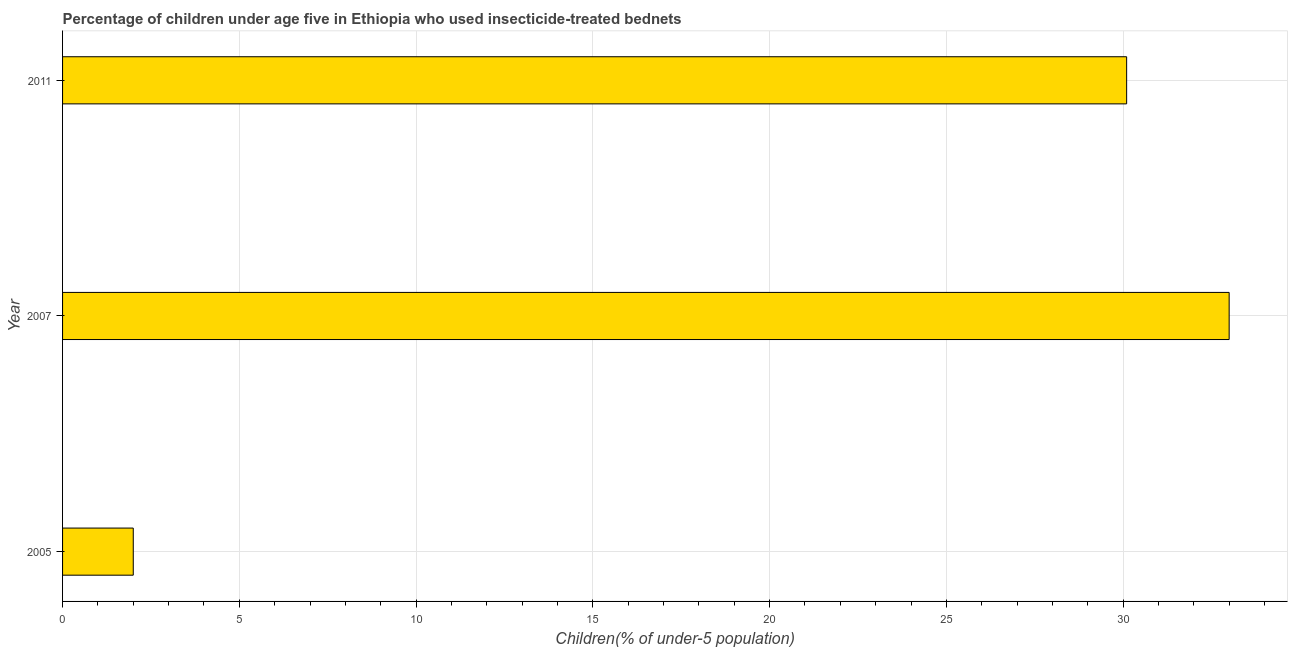What is the title of the graph?
Keep it short and to the point. Percentage of children under age five in Ethiopia who used insecticide-treated bednets. What is the label or title of the X-axis?
Offer a very short reply. Children(% of under-5 population). Across all years, what is the maximum percentage of children who use of insecticide-treated bed nets?
Your answer should be very brief. 33. Across all years, what is the minimum percentage of children who use of insecticide-treated bed nets?
Ensure brevity in your answer.  2. In which year was the percentage of children who use of insecticide-treated bed nets minimum?
Provide a succinct answer. 2005. What is the sum of the percentage of children who use of insecticide-treated bed nets?
Your answer should be compact. 65.1. What is the difference between the percentage of children who use of insecticide-treated bed nets in 2007 and 2011?
Give a very brief answer. 2.9. What is the average percentage of children who use of insecticide-treated bed nets per year?
Your response must be concise. 21.7. What is the median percentage of children who use of insecticide-treated bed nets?
Your answer should be compact. 30.1. In how many years, is the percentage of children who use of insecticide-treated bed nets greater than 31 %?
Give a very brief answer. 1. Do a majority of the years between 2011 and 2007 (inclusive) have percentage of children who use of insecticide-treated bed nets greater than 1 %?
Offer a very short reply. No. What is the ratio of the percentage of children who use of insecticide-treated bed nets in 2005 to that in 2011?
Ensure brevity in your answer.  0.07. Is the percentage of children who use of insecticide-treated bed nets in 2005 less than that in 2011?
Provide a short and direct response. Yes. Is the difference between the percentage of children who use of insecticide-treated bed nets in 2005 and 2007 greater than the difference between any two years?
Make the answer very short. Yes. What is the difference between the highest and the second highest percentage of children who use of insecticide-treated bed nets?
Provide a succinct answer. 2.9. Is the sum of the percentage of children who use of insecticide-treated bed nets in 2005 and 2007 greater than the maximum percentage of children who use of insecticide-treated bed nets across all years?
Your response must be concise. Yes. What is the difference between the highest and the lowest percentage of children who use of insecticide-treated bed nets?
Make the answer very short. 31. In how many years, is the percentage of children who use of insecticide-treated bed nets greater than the average percentage of children who use of insecticide-treated bed nets taken over all years?
Provide a succinct answer. 2. What is the Children(% of under-5 population) of 2005?
Give a very brief answer. 2. What is the Children(% of under-5 population) in 2011?
Ensure brevity in your answer.  30.1. What is the difference between the Children(% of under-5 population) in 2005 and 2007?
Your answer should be very brief. -31. What is the difference between the Children(% of under-5 population) in 2005 and 2011?
Your response must be concise. -28.1. What is the ratio of the Children(% of under-5 population) in 2005 to that in 2007?
Your response must be concise. 0.06. What is the ratio of the Children(% of under-5 population) in 2005 to that in 2011?
Ensure brevity in your answer.  0.07. What is the ratio of the Children(% of under-5 population) in 2007 to that in 2011?
Ensure brevity in your answer.  1.1. 